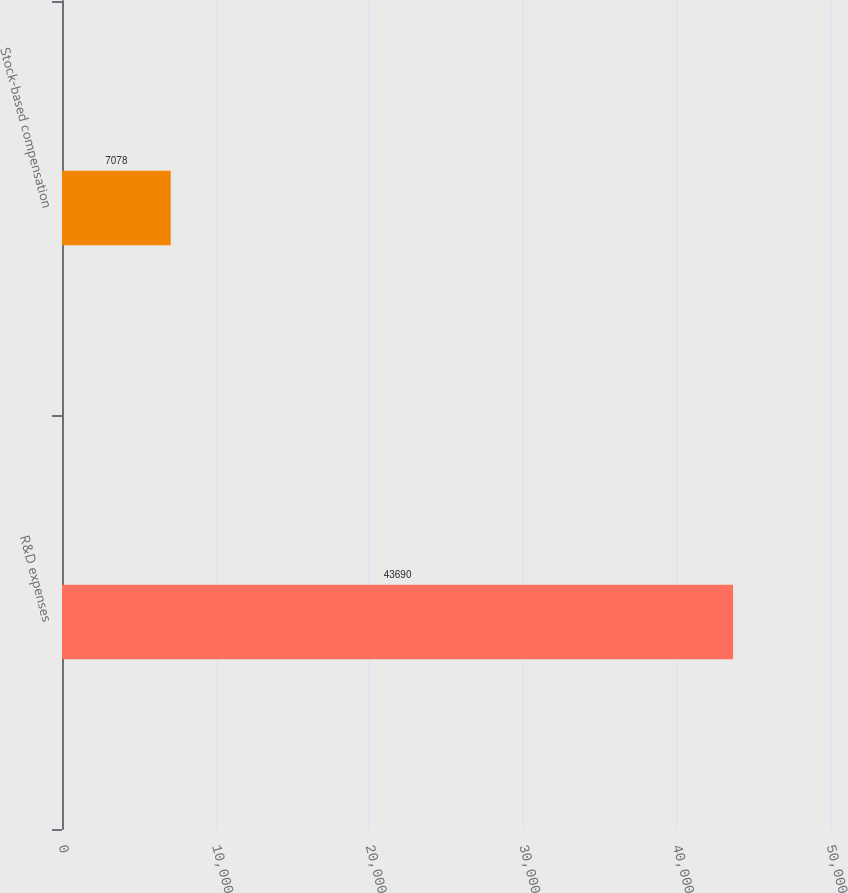Convert chart to OTSL. <chart><loc_0><loc_0><loc_500><loc_500><bar_chart><fcel>R&D expenses<fcel>Stock-based compensation<nl><fcel>43690<fcel>7078<nl></chart> 